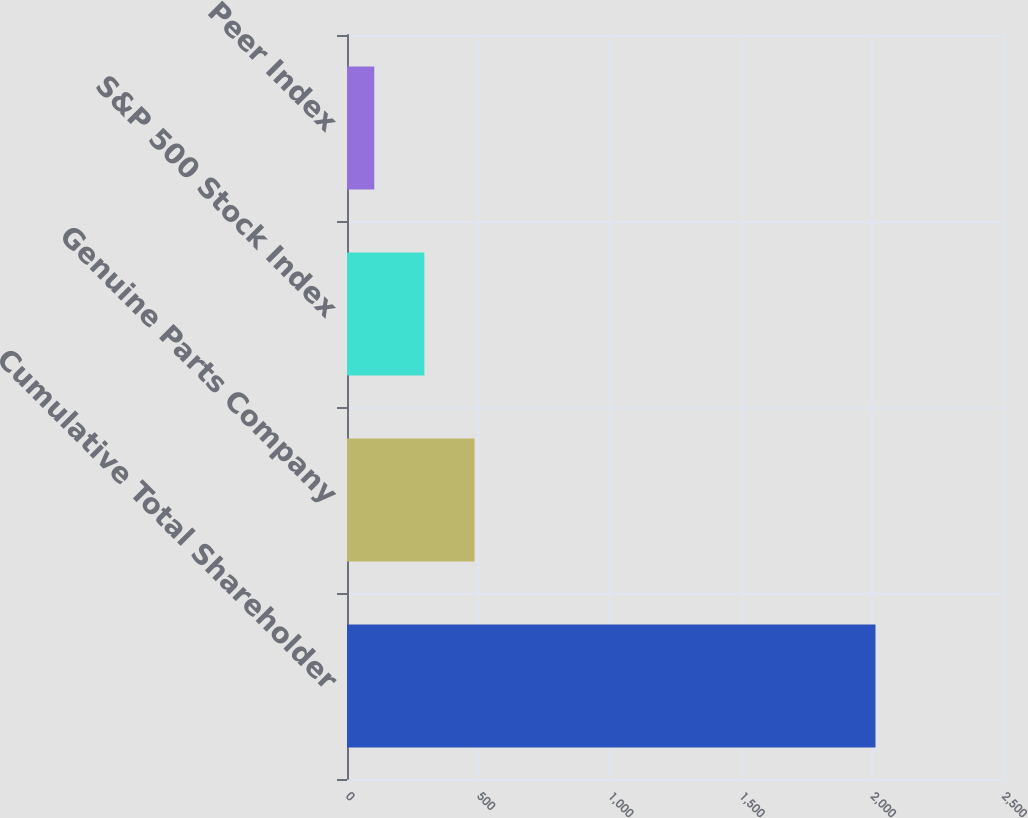<chart> <loc_0><loc_0><loc_500><loc_500><bar_chart><fcel>Cumulative Total Shareholder<fcel>Genuine Parts Company<fcel>S&P 500 Stock Index<fcel>Peer Index<nl><fcel>2014<fcel>485.94<fcel>294.93<fcel>103.92<nl></chart> 